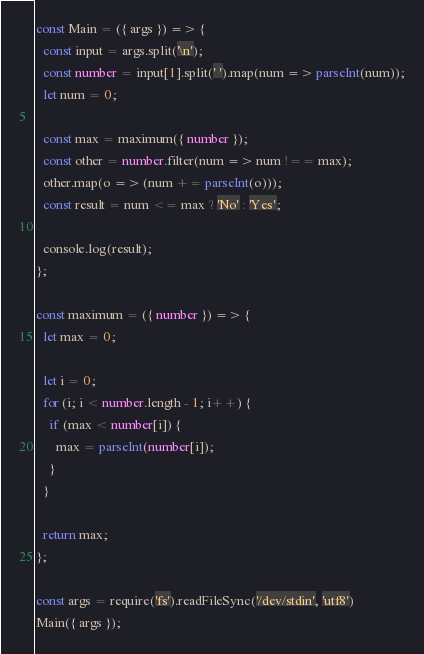<code> <loc_0><loc_0><loc_500><loc_500><_TypeScript_>const Main = ({ args }) => {
  const input = args.split('\n');
  const number = input[1].split(' ').map(num => parseInt(num));
  let num = 0;

  const max = maximum({ number });
  const other = number.filter(num => num !== max);
  other.map(o => (num += parseInt(o)));
  const result = num <= max ? 'No' : 'Yes';

  console.log(result);
};

const maximum = ({ number }) => {
  let max = 0;

  let i = 0;
  for (i; i < number.length - 1; i++) {
    if (max < number[i]) {
      max = parseInt(number[i]);
    }
  }

  return max;
};

const args = require('fs').readFileSync('/dev/stdin', 'utf8')
Main({ args });</code> 